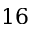<formula> <loc_0><loc_0><loc_500><loc_500>1 6</formula> 